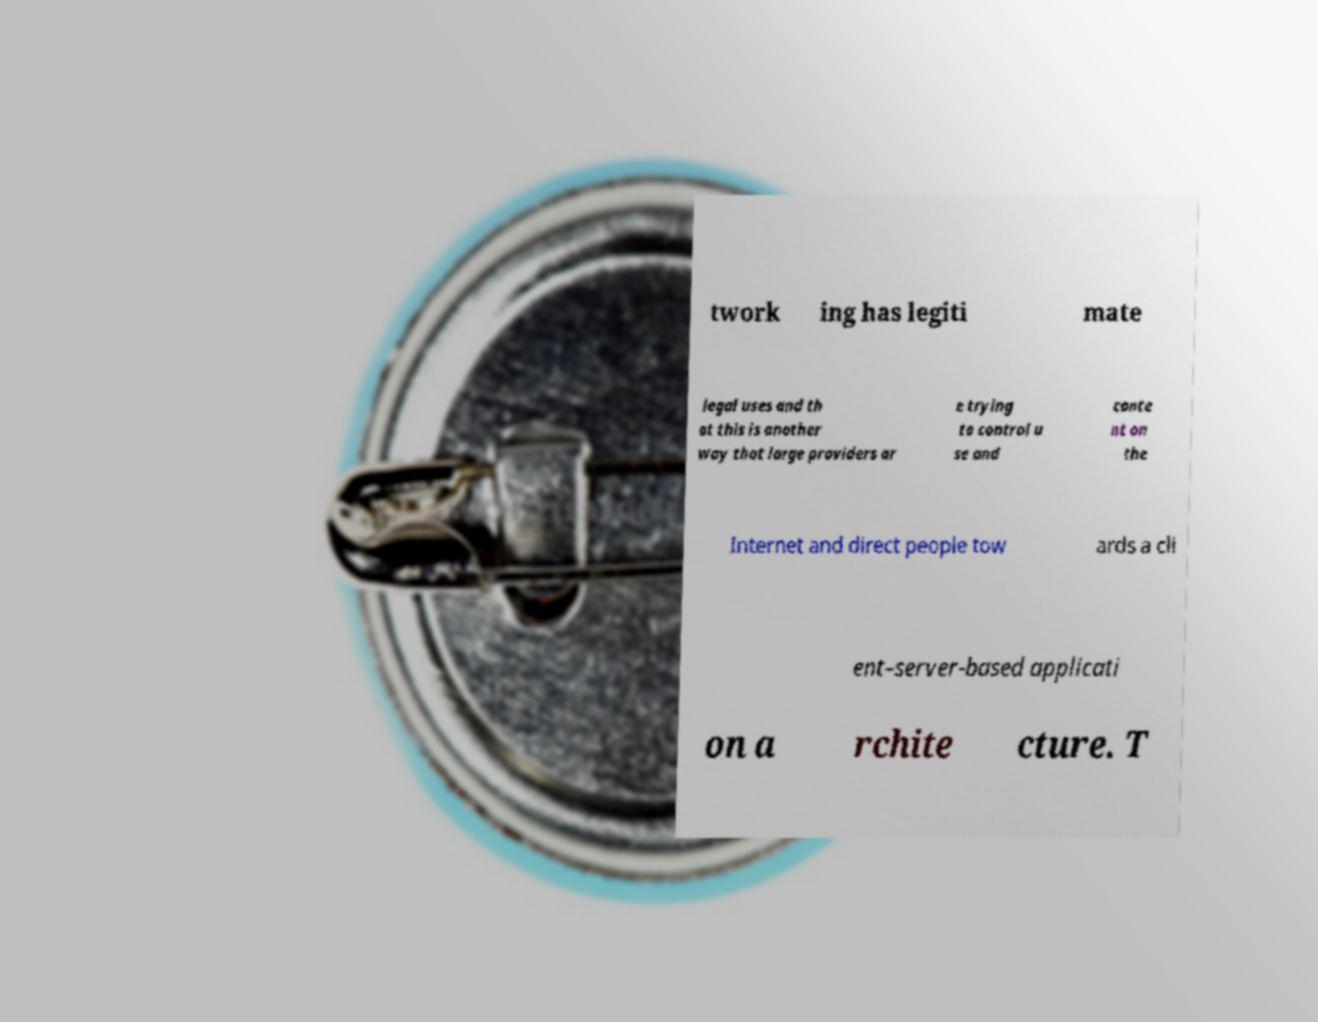Please identify and transcribe the text found in this image. twork ing has legiti mate legal uses and th at this is another way that large providers ar e trying to control u se and conte nt on the Internet and direct people tow ards a cli ent–server-based applicati on a rchite cture. T 